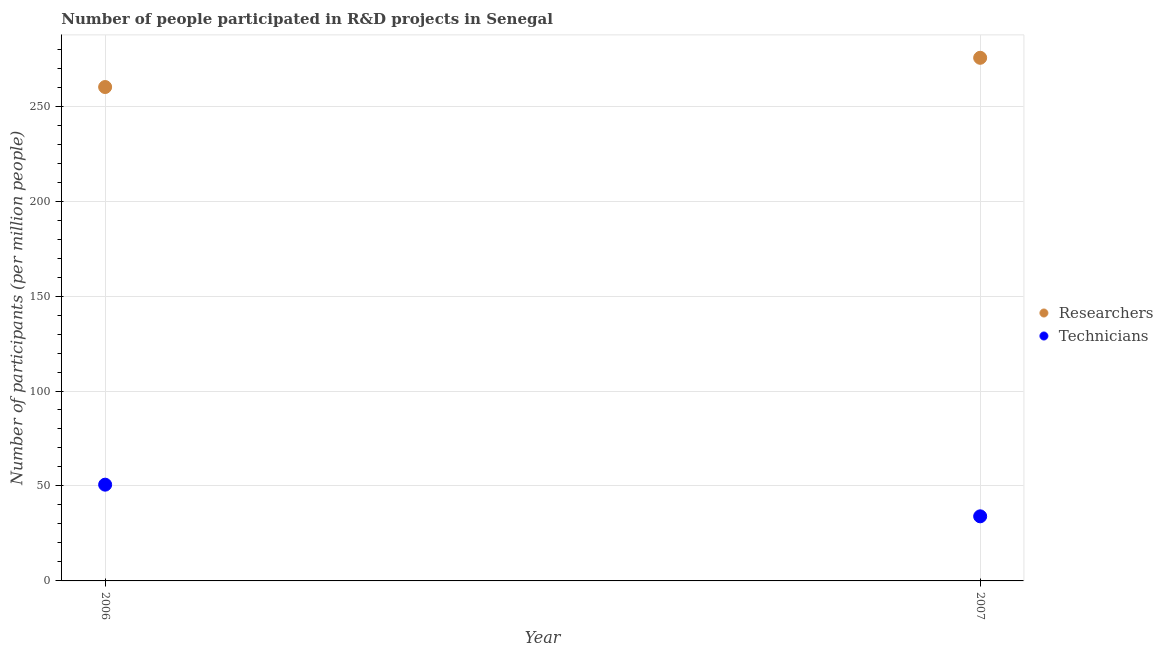How many different coloured dotlines are there?
Ensure brevity in your answer.  2. What is the number of technicians in 2006?
Your answer should be very brief. 50.68. Across all years, what is the maximum number of researchers?
Your response must be concise. 275.44. Across all years, what is the minimum number of technicians?
Offer a terse response. 34.01. In which year was the number of researchers maximum?
Your answer should be compact. 2007. What is the total number of researchers in the graph?
Your answer should be compact. 535.49. What is the difference between the number of researchers in 2006 and that in 2007?
Your answer should be compact. -15.39. What is the difference between the number of technicians in 2007 and the number of researchers in 2006?
Provide a succinct answer. -226.04. What is the average number of researchers per year?
Your response must be concise. 267.75. In the year 2007, what is the difference between the number of researchers and number of technicians?
Offer a very short reply. 241.43. In how many years, is the number of researchers greater than 270?
Offer a terse response. 1. What is the ratio of the number of technicians in 2006 to that in 2007?
Your answer should be very brief. 1.49. Is the number of researchers in 2006 less than that in 2007?
Offer a very short reply. Yes. In how many years, is the number of researchers greater than the average number of researchers taken over all years?
Provide a short and direct response. 1. Does the number of technicians monotonically increase over the years?
Provide a succinct answer. No. Is the number of researchers strictly greater than the number of technicians over the years?
Your answer should be compact. Yes. Does the graph contain any zero values?
Ensure brevity in your answer.  No. Does the graph contain grids?
Make the answer very short. Yes. Where does the legend appear in the graph?
Give a very brief answer. Center right. How many legend labels are there?
Offer a very short reply. 2. How are the legend labels stacked?
Keep it short and to the point. Vertical. What is the title of the graph?
Keep it short and to the point. Number of people participated in R&D projects in Senegal. What is the label or title of the X-axis?
Your response must be concise. Year. What is the label or title of the Y-axis?
Keep it short and to the point. Number of participants (per million people). What is the Number of participants (per million people) of Researchers in 2006?
Your answer should be compact. 260.05. What is the Number of participants (per million people) in Technicians in 2006?
Your answer should be compact. 50.68. What is the Number of participants (per million people) of Researchers in 2007?
Your answer should be compact. 275.44. What is the Number of participants (per million people) of Technicians in 2007?
Provide a succinct answer. 34.01. Across all years, what is the maximum Number of participants (per million people) of Researchers?
Keep it short and to the point. 275.44. Across all years, what is the maximum Number of participants (per million people) in Technicians?
Make the answer very short. 50.68. Across all years, what is the minimum Number of participants (per million people) in Researchers?
Keep it short and to the point. 260.05. Across all years, what is the minimum Number of participants (per million people) of Technicians?
Your response must be concise. 34.01. What is the total Number of participants (per million people) of Researchers in the graph?
Ensure brevity in your answer.  535.49. What is the total Number of participants (per million people) in Technicians in the graph?
Provide a succinct answer. 84.69. What is the difference between the Number of participants (per million people) in Researchers in 2006 and that in 2007?
Your response must be concise. -15.39. What is the difference between the Number of participants (per million people) of Technicians in 2006 and that in 2007?
Give a very brief answer. 16.67. What is the difference between the Number of participants (per million people) in Researchers in 2006 and the Number of participants (per million people) in Technicians in 2007?
Give a very brief answer. 226.04. What is the average Number of participants (per million people) of Researchers per year?
Give a very brief answer. 267.75. What is the average Number of participants (per million people) in Technicians per year?
Provide a short and direct response. 42.35. In the year 2006, what is the difference between the Number of participants (per million people) of Researchers and Number of participants (per million people) of Technicians?
Offer a terse response. 209.37. In the year 2007, what is the difference between the Number of participants (per million people) in Researchers and Number of participants (per million people) in Technicians?
Ensure brevity in your answer.  241.43. What is the ratio of the Number of participants (per million people) in Researchers in 2006 to that in 2007?
Make the answer very short. 0.94. What is the ratio of the Number of participants (per million people) in Technicians in 2006 to that in 2007?
Provide a short and direct response. 1.49. What is the difference between the highest and the second highest Number of participants (per million people) in Researchers?
Your answer should be very brief. 15.39. What is the difference between the highest and the second highest Number of participants (per million people) in Technicians?
Give a very brief answer. 16.67. What is the difference between the highest and the lowest Number of participants (per million people) in Researchers?
Your response must be concise. 15.39. What is the difference between the highest and the lowest Number of participants (per million people) of Technicians?
Provide a succinct answer. 16.67. 